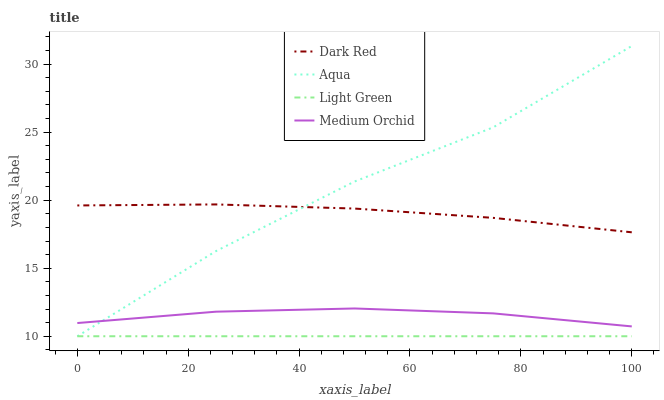Does Light Green have the minimum area under the curve?
Answer yes or no. Yes. Does Aqua have the maximum area under the curve?
Answer yes or no. Yes. Does Medium Orchid have the minimum area under the curve?
Answer yes or no. No. Does Medium Orchid have the maximum area under the curve?
Answer yes or no. No. Is Light Green the smoothest?
Answer yes or no. Yes. Is Aqua the roughest?
Answer yes or no. Yes. Is Medium Orchid the smoothest?
Answer yes or no. No. Is Medium Orchid the roughest?
Answer yes or no. No. Does Aqua have the lowest value?
Answer yes or no. Yes. Does Medium Orchid have the lowest value?
Answer yes or no. No. Does Aqua have the highest value?
Answer yes or no. Yes. Does Medium Orchid have the highest value?
Answer yes or no. No. Is Medium Orchid less than Dark Red?
Answer yes or no. Yes. Is Dark Red greater than Light Green?
Answer yes or no. Yes. Does Dark Red intersect Aqua?
Answer yes or no. Yes. Is Dark Red less than Aqua?
Answer yes or no. No. Is Dark Red greater than Aqua?
Answer yes or no. No. Does Medium Orchid intersect Dark Red?
Answer yes or no. No. 